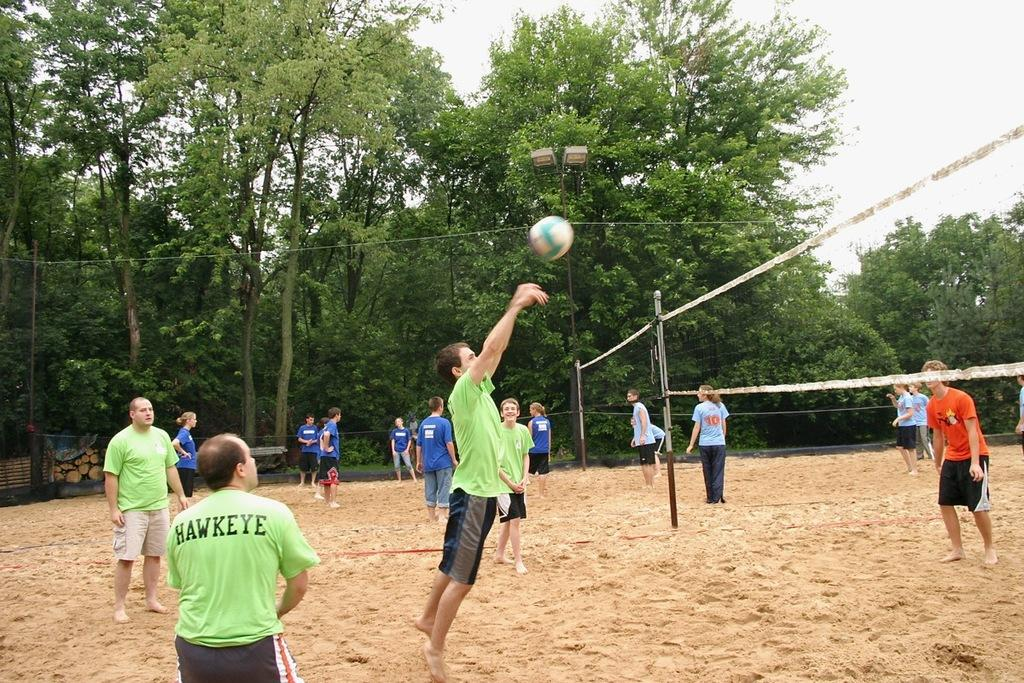Provide a one-sentence caption for the provided image. A man named Hawkeye is playing volleyball with a bunch of other people. 